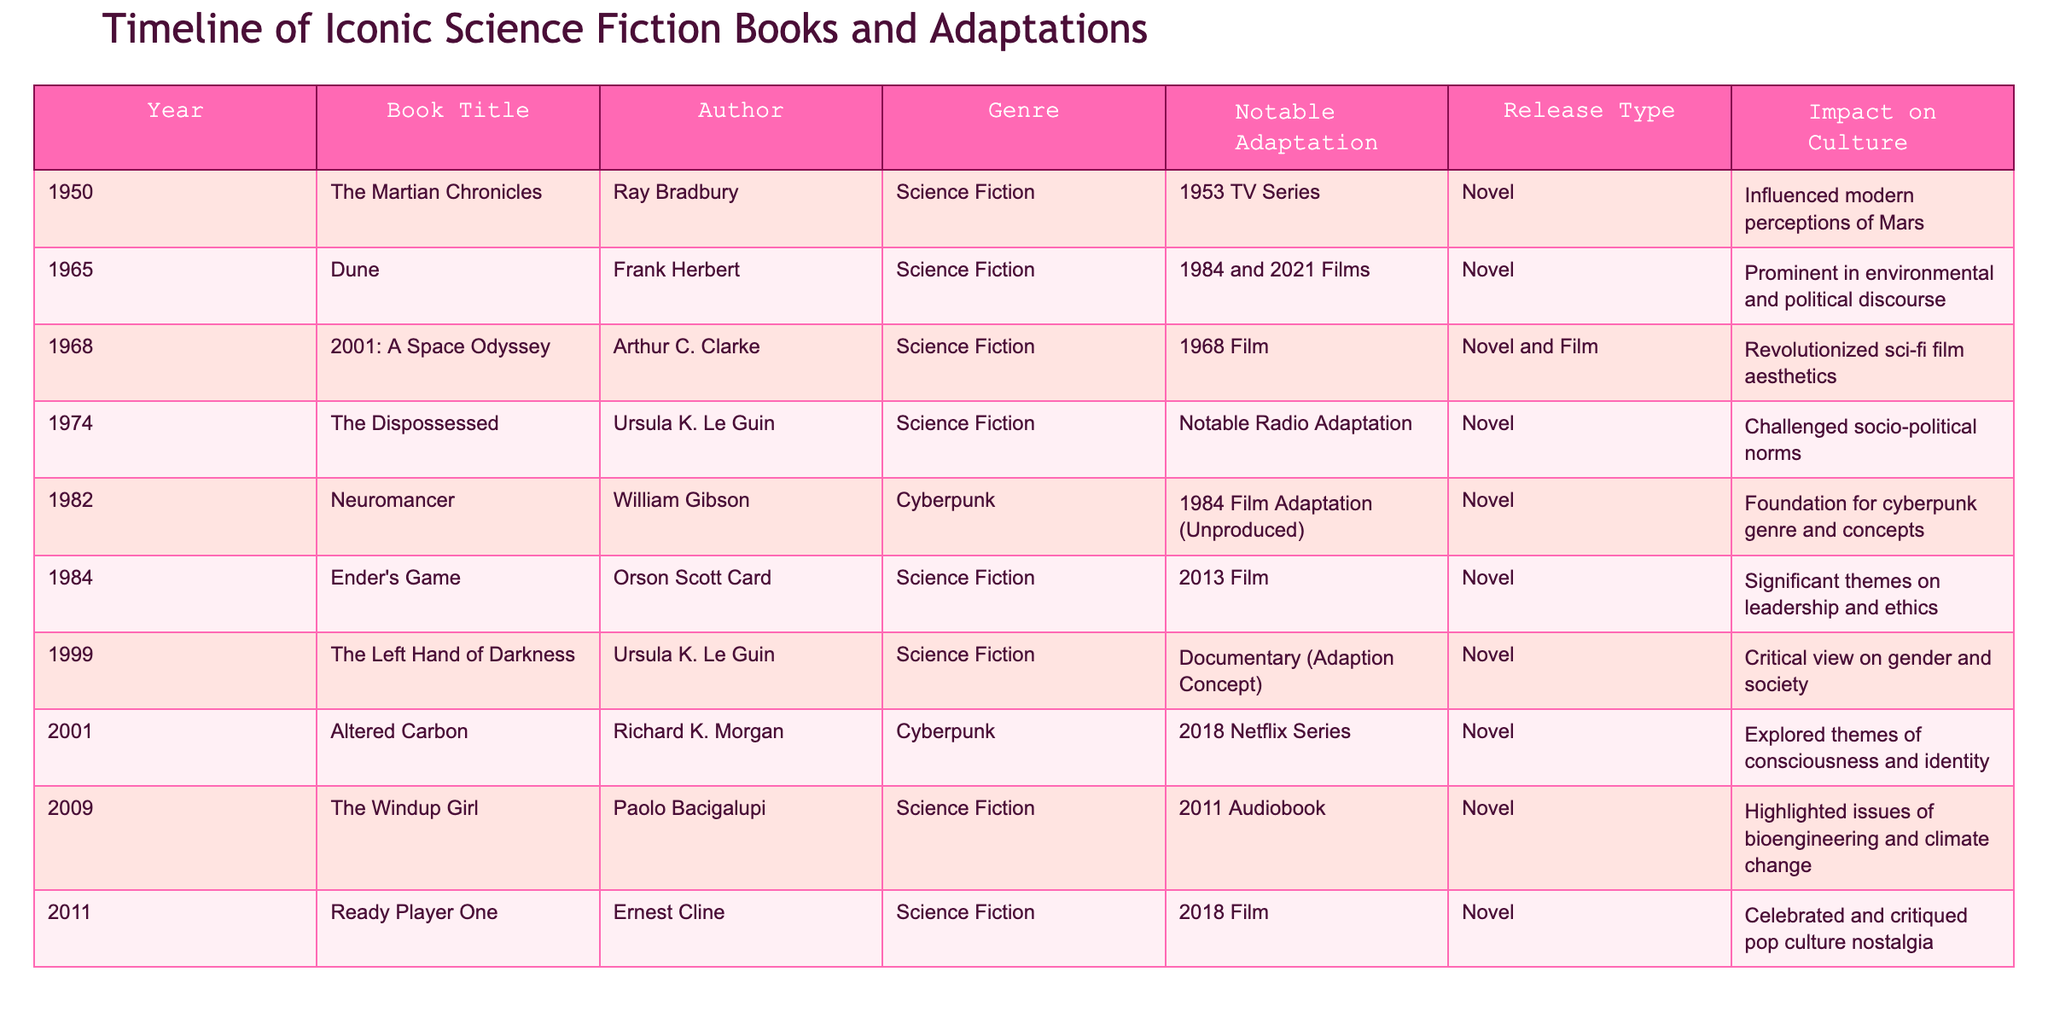What year was "Dune" published? The table lists the year of publication next to each book title. For "Dune," the corresponding year is 1965.
Answer: 1965 Which book had a significant impact on environmental and political discourse? The table indicates that "Dune" by Frank Herbert had a prominent impact on environmental and political discourse.
Answer: Dune How many cyberpunk novels are listed in the table? Looking through the "Genre" column, there are two titles categorized under "Cyberpunk": "Neuromancer" and "Altered Carbon."
Answer: 2 What notable adaptation did "The Martian Chronicles" have? The table shows that "The Martian Chronicles" had a notable adaptation as a 1953 TV Series.
Answer: 1953 TV Series Which author is known for having two works in the table? By inspecting the "Author" column, both "The Dispossessed" and "The Left Hand of Darkness" are attributed to Ursula K. Le Guin.
Answer: Ursula K. Le Guin Was there a film adaptation for "Ender's Game"? The table confirms that "Ender's Game" had a notable adaptation in the form of a 2013 Film.
Answer: Yes Which book was released in 2001, and what was its notable adaptation? The entry for 2001 mentions "Altered Carbon," which had a notable adaptation as a 2018 Netflix Series.
Answer: Altered Carbon; 2018 Netflix Series What impact did "Neuromancer" have on the genre? According to the table, "Neuromancer" is noted as foundational for the cyberpunk genre and concepts.
Answer: Foundation for cyberpunk genre How many distinct genres are represented in the table? By analyzing the "Genre" column, we find three distinct genres: Science Fiction, Cyberpunk, and a specific reference to one entry under Cyberpunk. Considering repeated entries, the unique genres are Science Fiction and Cyberpunk, totaling two.
Answer: 2 Which book had its adaptation concept presented in a documentary? The table specifies that "The Left Hand of Darkness" had a documentary as its notable adaptation concept.
Answer: The Left Hand of Darkness What is the notable theme of "Ready Player One"? The table states that "Ready Player One" celebrated and critiqued pop culture nostalgia, which is its notable theme.
Answer: Pop culture nostalgia 